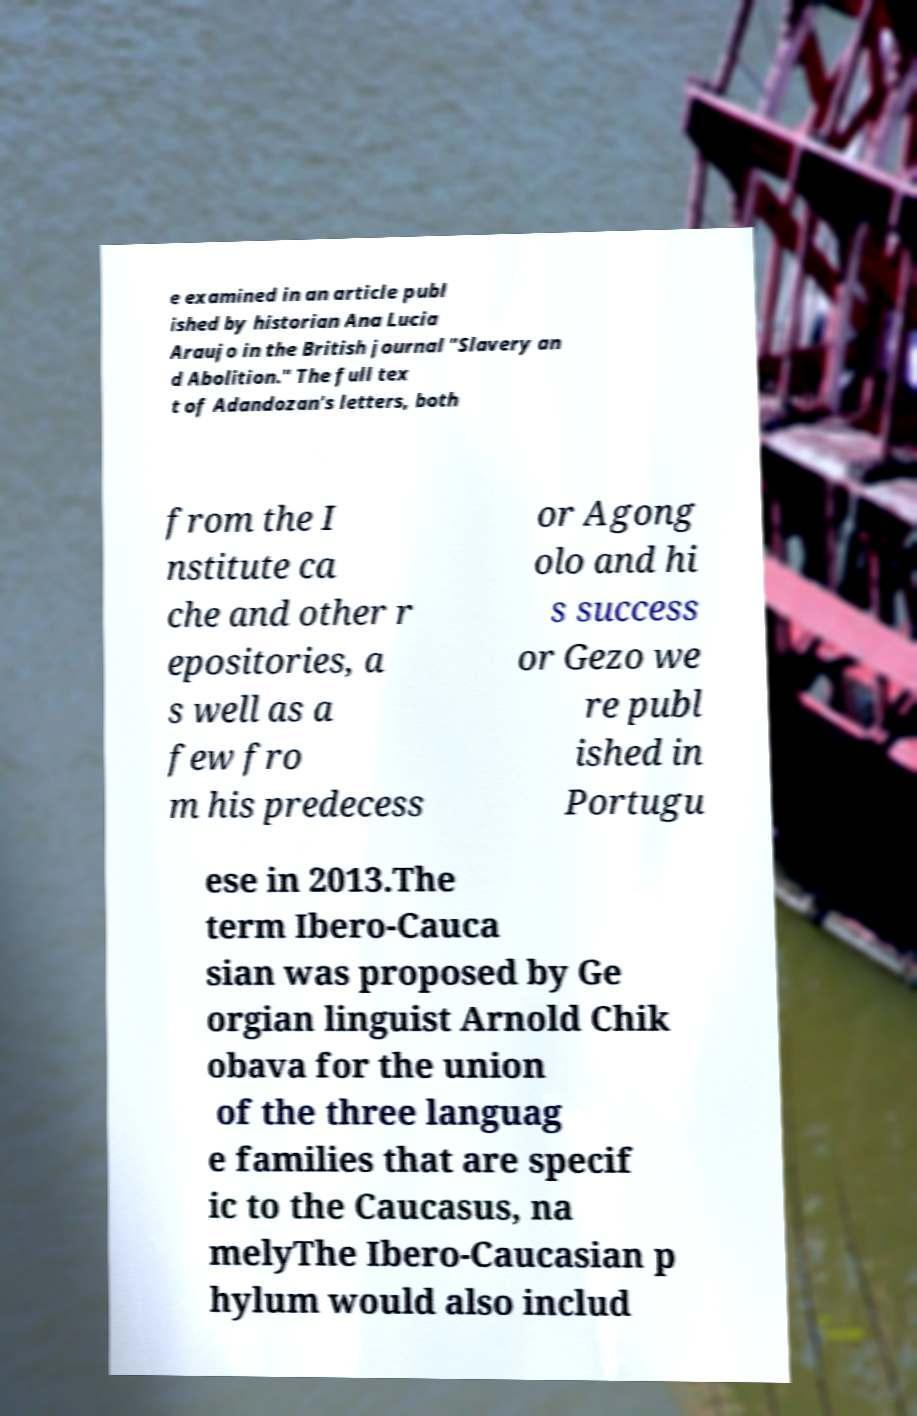Can you accurately transcribe the text from the provided image for me? e examined in an article publ ished by historian Ana Lucia Araujo in the British journal "Slavery an d Abolition." The full tex t of Adandozan's letters, both from the I nstitute ca che and other r epositories, a s well as a few fro m his predecess or Agong olo and hi s success or Gezo we re publ ished in Portugu ese in 2013.The term Ibero-Cauca sian was proposed by Ge orgian linguist Arnold Chik obava for the union of the three languag e families that are specif ic to the Caucasus, na melyThe Ibero-Caucasian p hylum would also includ 